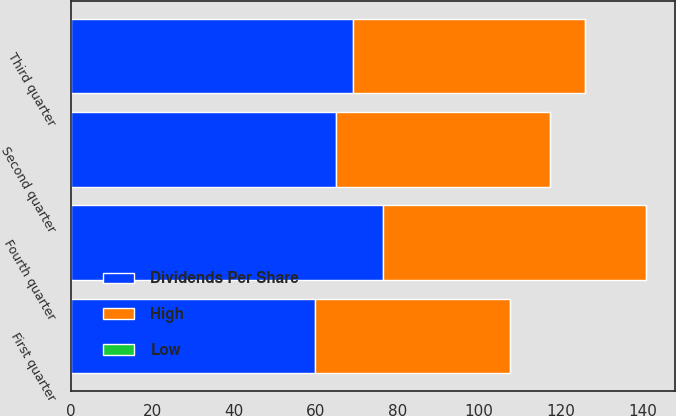Convert chart to OTSL. <chart><loc_0><loc_0><loc_500><loc_500><stacked_bar_chart><ecel><fcel>First quarter<fcel>Second quarter<fcel>Third quarter<fcel>Fourth quarter<nl><fcel>Dividends Per Share<fcel>59.9<fcel>64.9<fcel>69<fcel>76.56<nl><fcel>High<fcel>47.73<fcel>52.38<fcel>57.04<fcel>64.39<nl><fcel>Low<fcel>0.03<fcel>0.03<fcel>0.03<fcel>0.04<nl></chart> 